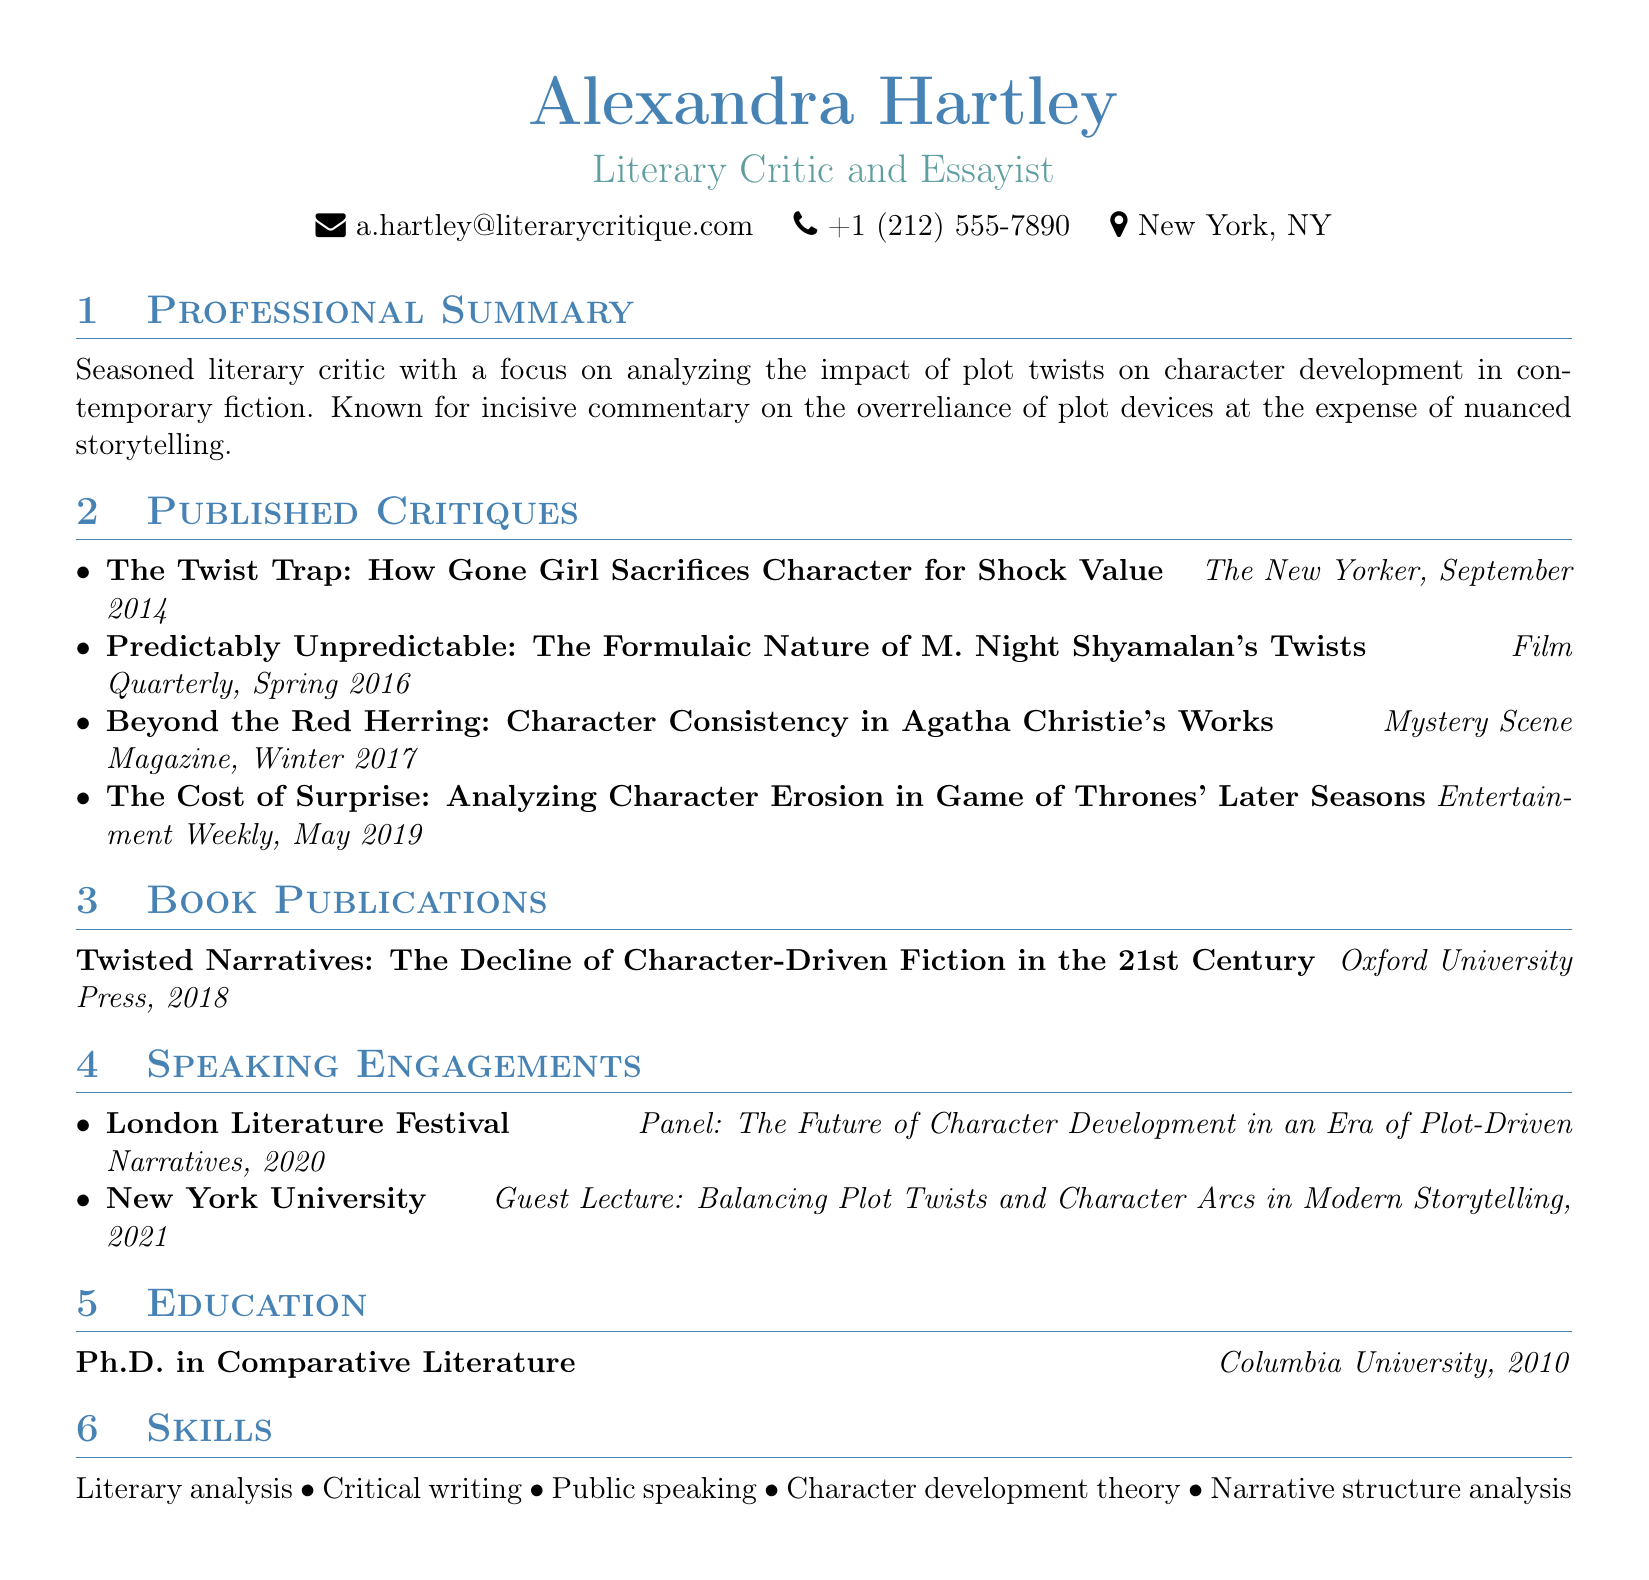what is the name of the critic? The name of the critic is presented prominently at the top of the document.
Answer: Alexandra Hartley what is the primary focus of Alexandra Hartley's criticism? The professional summary describes the main focus of the critic's work.
Answer: Analyzing the impact of plot twists on character development how many critiques has Alexandra Hartley published? The number of published critiques is determined by counting the items listed in the section.
Answer: Four what is the title of the book published by Alexandra Hartley? The book publication section lists the title of the book authored by the critic.
Answer: Twisted Narratives: The Decline of Character-Driven Fiction in the 21st Century which publication featured the critique titled "The Twist Trap: How Gone Girl Sacrifices Character for Shock Value"? The specific critique title and its corresponding publication are provided in the list of published critiques.
Answer: The New Yorker in what year did Alexandra Hartley obtain her Ph.D.? The education section indicates the year of the degree completion.
Answer: 2010 what event did Alexandra Hartley participate in during 2020? The speaking engagements section lists the events and the years in which the critic participated.
Answer: London Literature Festival what topic did Alexandra Hartley discuss during her guest lecture at New York University? The specific topic of the guest lecture is outlined in the speaking engagements section.
Answer: Balancing Plot Twists and Character Arcs in Modern Storytelling 